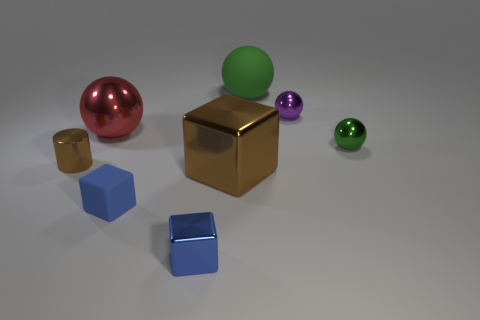How many tiny purple metal objects are the same shape as the green metallic object?
Provide a short and direct response. 1. The green object that is the same size as the red shiny thing is what shape?
Your answer should be compact. Sphere. Are there any purple things in front of the cylinder?
Keep it short and to the point. No. There is a green sphere left of the green metallic object; is there a tiny purple metallic sphere behind it?
Your answer should be very brief. No. Is the number of blue shiny cubes that are to the left of the red metallic object less than the number of green matte balls behind the green metal object?
Offer a very short reply. Yes. Is there anything else that is the same size as the green matte sphere?
Your answer should be very brief. Yes. What shape is the small brown object?
Offer a terse response. Cylinder. What is the material of the small blue object right of the small matte cube?
Make the answer very short. Metal. What size is the blue block in front of the matte thing that is in front of the small thing left of the blue matte block?
Keep it short and to the point. Small. Does the green ball that is behind the purple shiny thing have the same material as the brown thing behind the large brown metal thing?
Ensure brevity in your answer.  No. 